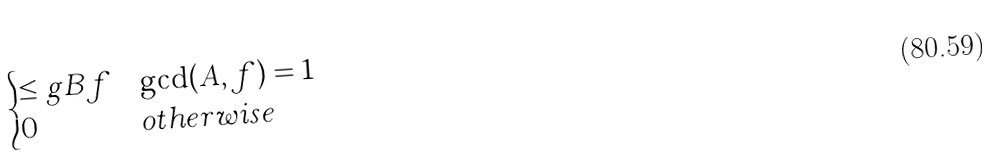Convert formula to latex. <formula><loc_0><loc_0><loc_500><loc_500>\begin{cases} \leq g { B } { f } & \gcd ( A , f ) = 1 \\ 0 & o t h e r w i s e \end{cases}</formula> 